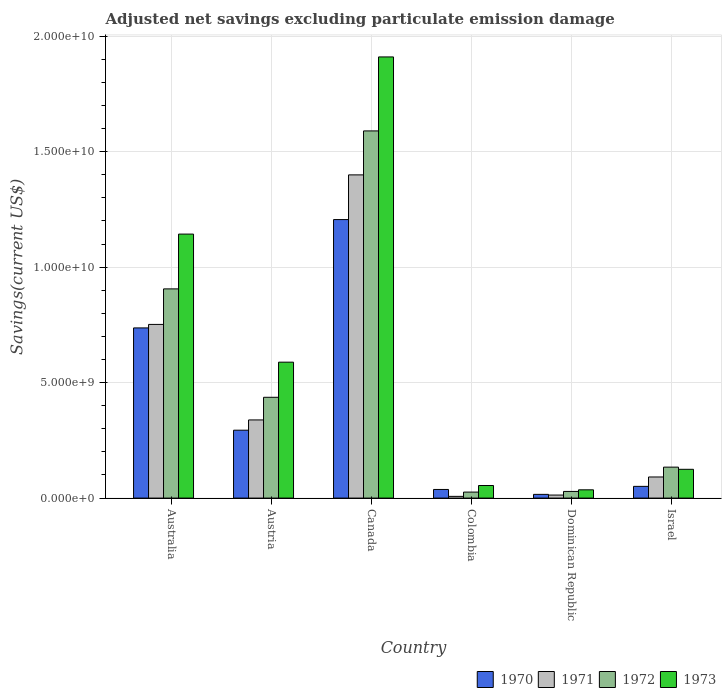How many different coloured bars are there?
Give a very brief answer. 4. How many groups of bars are there?
Give a very brief answer. 6. How many bars are there on the 6th tick from the right?
Keep it short and to the point. 4. What is the label of the 4th group of bars from the left?
Provide a short and direct response. Colombia. In how many cases, is the number of bars for a given country not equal to the number of legend labels?
Offer a terse response. 0. What is the adjusted net savings in 1971 in Dominican Republic?
Ensure brevity in your answer.  1.32e+08. Across all countries, what is the maximum adjusted net savings in 1972?
Ensure brevity in your answer.  1.59e+1. Across all countries, what is the minimum adjusted net savings in 1971?
Make the answer very short. 7.46e+07. In which country was the adjusted net savings in 1972 maximum?
Your answer should be very brief. Canada. In which country was the adjusted net savings in 1972 minimum?
Provide a succinct answer. Colombia. What is the total adjusted net savings in 1973 in the graph?
Provide a short and direct response. 3.86e+1. What is the difference between the adjusted net savings in 1972 in Austria and that in Canada?
Offer a very short reply. -1.15e+1. What is the difference between the adjusted net savings in 1971 in Canada and the adjusted net savings in 1970 in Israel?
Offer a very short reply. 1.35e+1. What is the average adjusted net savings in 1970 per country?
Provide a short and direct response. 3.90e+09. What is the difference between the adjusted net savings of/in 1970 and adjusted net savings of/in 1972 in Austria?
Provide a succinct answer. -1.43e+09. In how many countries, is the adjusted net savings in 1970 greater than 1000000000 US$?
Keep it short and to the point. 3. What is the ratio of the adjusted net savings in 1970 in Dominican Republic to that in Israel?
Your response must be concise. 0.32. Is the adjusted net savings in 1971 in Australia less than that in Austria?
Make the answer very short. No. What is the difference between the highest and the second highest adjusted net savings in 1970?
Make the answer very short. 9.12e+09. What is the difference between the highest and the lowest adjusted net savings in 1970?
Keep it short and to the point. 1.19e+1. Is the sum of the adjusted net savings in 1972 in Canada and Colombia greater than the maximum adjusted net savings in 1973 across all countries?
Give a very brief answer. No. Is it the case that in every country, the sum of the adjusted net savings in 1972 and adjusted net savings in 1973 is greater than the sum of adjusted net savings in 1971 and adjusted net savings in 1970?
Keep it short and to the point. No. How many bars are there?
Offer a very short reply. 24. Are all the bars in the graph horizontal?
Your response must be concise. No. What is the difference between two consecutive major ticks on the Y-axis?
Your response must be concise. 5.00e+09. How are the legend labels stacked?
Provide a succinct answer. Horizontal. What is the title of the graph?
Your response must be concise. Adjusted net savings excluding particulate emission damage. Does "2003" appear as one of the legend labels in the graph?
Provide a short and direct response. No. What is the label or title of the X-axis?
Provide a short and direct response. Country. What is the label or title of the Y-axis?
Offer a very short reply. Savings(current US$). What is the Savings(current US$) in 1970 in Australia?
Ensure brevity in your answer.  7.37e+09. What is the Savings(current US$) in 1971 in Australia?
Your answer should be very brief. 7.52e+09. What is the Savings(current US$) in 1972 in Australia?
Ensure brevity in your answer.  9.06e+09. What is the Savings(current US$) of 1973 in Australia?
Give a very brief answer. 1.14e+1. What is the Savings(current US$) in 1970 in Austria?
Your response must be concise. 2.94e+09. What is the Savings(current US$) in 1971 in Austria?
Ensure brevity in your answer.  3.38e+09. What is the Savings(current US$) in 1972 in Austria?
Offer a very short reply. 4.37e+09. What is the Savings(current US$) in 1973 in Austria?
Your answer should be compact. 5.89e+09. What is the Savings(current US$) in 1970 in Canada?
Your answer should be very brief. 1.21e+1. What is the Savings(current US$) of 1971 in Canada?
Offer a terse response. 1.40e+1. What is the Savings(current US$) in 1972 in Canada?
Offer a terse response. 1.59e+1. What is the Savings(current US$) of 1973 in Canada?
Make the answer very short. 1.91e+1. What is the Savings(current US$) of 1970 in Colombia?
Provide a succinct answer. 3.74e+08. What is the Savings(current US$) in 1971 in Colombia?
Offer a terse response. 7.46e+07. What is the Savings(current US$) of 1972 in Colombia?
Offer a terse response. 2.60e+08. What is the Savings(current US$) in 1973 in Colombia?
Provide a succinct answer. 5.45e+08. What is the Savings(current US$) in 1970 in Dominican Republic?
Keep it short and to the point. 1.61e+08. What is the Savings(current US$) in 1971 in Dominican Republic?
Give a very brief answer. 1.32e+08. What is the Savings(current US$) of 1972 in Dominican Republic?
Your answer should be compact. 2.89e+08. What is the Savings(current US$) of 1973 in Dominican Republic?
Offer a terse response. 3.58e+08. What is the Savings(current US$) in 1970 in Israel?
Keep it short and to the point. 5.08e+08. What is the Savings(current US$) in 1971 in Israel?
Your answer should be very brief. 9.14e+08. What is the Savings(current US$) of 1972 in Israel?
Your answer should be very brief. 1.34e+09. What is the Savings(current US$) in 1973 in Israel?
Ensure brevity in your answer.  1.25e+09. Across all countries, what is the maximum Savings(current US$) in 1970?
Ensure brevity in your answer.  1.21e+1. Across all countries, what is the maximum Savings(current US$) of 1971?
Offer a very short reply. 1.40e+1. Across all countries, what is the maximum Savings(current US$) of 1972?
Your response must be concise. 1.59e+1. Across all countries, what is the maximum Savings(current US$) of 1973?
Keep it short and to the point. 1.91e+1. Across all countries, what is the minimum Savings(current US$) in 1970?
Give a very brief answer. 1.61e+08. Across all countries, what is the minimum Savings(current US$) in 1971?
Offer a very short reply. 7.46e+07. Across all countries, what is the minimum Savings(current US$) of 1972?
Keep it short and to the point. 2.60e+08. Across all countries, what is the minimum Savings(current US$) in 1973?
Keep it short and to the point. 3.58e+08. What is the total Savings(current US$) in 1970 in the graph?
Your answer should be compact. 2.34e+1. What is the total Savings(current US$) of 1971 in the graph?
Offer a very short reply. 2.60e+1. What is the total Savings(current US$) in 1972 in the graph?
Ensure brevity in your answer.  3.12e+1. What is the total Savings(current US$) in 1973 in the graph?
Your answer should be very brief. 3.86e+1. What is the difference between the Savings(current US$) in 1970 in Australia and that in Austria?
Provide a succinct answer. 4.43e+09. What is the difference between the Savings(current US$) in 1971 in Australia and that in Austria?
Give a very brief answer. 4.14e+09. What is the difference between the Savings(current US$) of 1972 in Australia and that in Austria?
Provide a short and direct response. 4.69e+09. What is the difference between the Savings(current US$) of 1973 in Australia and that in Austria?
Keep it short and to the point. 5.55e+09. What is the difference between the Savings(current US$) of 1970 in Australia and that in Canada?
Offer a terse response. -4.69e+09. What is the difference between the Savings(current US$) in 1971 in Australia and that in Canada?
Keep it short and to the point. -6.48e+09. What is the difference between the Savings(current US$) in 1972 in Australia and that in Canada?
Your response must be concise. -6.84e+09. What is the difference between the Savings(current US$) of 1973 in Australia and that in Canada?
Provide a short and direct response. -7.67e+09. What is the difference between the Savings(current US$) of 1970 in Australia and that in Colombia?
Make the answer very short. 7.00e+09. What is the difference between the Savings(current US$) of 1971 in Australia and that in Colombia?
Make the answer very short. 7.45e+09. What is the difference between the Savings(current US$) in 1972 in Australia and that in Colombia?
Keep it short and to the point. 8.80e+09. What is the difference between the Savings(current US$) of 1973 in Australia and that in Colombia?
Your answer should be very brief. 1.09e+1. What is the difference between the Savings(current US$) of 1970 in Australia and that in Dominican Republic?
Your answer should be very brief. 7.21e+09. What is the difference between the Savings(current US$) of 1971 in Australia and that in Dominican Republic?
Your response must be concise. 7.39e+09. What is the difference between the Savings(current US$) of 1972 in Australia and that in Dominican Republic?
Provide a succinct answer. 8.77e+09. What is the difference between the Savings(current US$) of 1973 in Australia and that in Dominican Republic?
Your response must be concise. 1.11e+1. What is the difference between the Savings(current US$) of 1970 in Australia and that in Israel?
Your response must be concise. 6.86e+09. What is the difference between the Savings(current US$) of 1971 in Australia and that in Israel?
Keep it short and to the point. 6.61e+09. What is the difference between the Savings(current US$) of 1972 in Australia and that in Israel?
Your response must be concise. 7.72e+09. What is the difference between the Savings(current US$) in 1973 in Australia and that in Israel?
Give a very brief answer. 1.02e+1. What is the difference between the Savings(current US$) of 1970 in Austria and that in Canada?
Provide a short and direct response. -9.12e+09. What is the difference between the Savings(current US$) in 1971 in Austria and that in Canada?
Your answer should be very brief. -1.06e+1. What is the difference between the Savings(current US$) of 1972 in Austria and that in Canada?
Your answer should be very brief. -1.15e+1. What is the difference between the Savings(current US$) in 1973 in Austria and that in Canada?
Your answer should be compact. -1.32e+1. What is the difference between the Savings(current US$) of 1970 in Austria and that in Colombia?
Your answer should be compact. 2.57e+09. What is the difference between the Savings(current US$) in 1971 in Austria and that in Colombia?
Your response must be concise. 3.31e+09. What is the difference between the Savings(current US$) in 1972 in Austria and that in Colombia?
Offer a terse response. 4.11e+09. What is the difference between the Savings(current US$) of 1973 in Austria and that in Colombia?
Make the answer very short. 5.34e+09. What is the difference between the Savings(current US$) of 1970 in Austria and that in Dominican Republic?
Provide a succinct answer. 2.78e+09. What is the difference between the Savings(current US$) of 1971 in Austria and that in Dominican Republic?
Your response must be concise. 3.25e+09. What is the difference between the Savings(current US$) of 1972 in Austria and that in Dominican Republic?
Your answer should be compact. 4.08e+09. What is the difference between the Savings(current US$) of 1973 in Austria and that in Dominican Republic?
Offer a terse response. 5.53e+09. What is the difference between the Savings(current US$) in 1970 in Austria and that in Israel?
Keep it short and to the point. 2.43e+09. What is the difference between the Savings(current US$) in 1971 in Austria and that in Israel?
Offer a very short reply. 2.47e+09. What is the difference between the Savings(current US$) in 1972 in Austria and that in Israel?
Your response must be concise. 3.02e+09. What is the difference between the Savings(current US$) of 1973 in Austria and that in Israel?
Your answer should be very brief. 4.64e+09. What is the difference between the Savings(current US$) of 1970 in Canada and that in Colombia?
Give a very brief answer. 1.17e+1. What is the difference between the Savings(current US$) in 1971 in Canada and that in Colombia?
Keep it short and to the point. 1.39e+1. What is the difference between the Savings(current US$) in 1972 in Canada and that in Colombia?
Make the answer very short. 1.56e+1. What is the difference between the Savings(current US$) in 1973 in Canada and that in Colombia?
Provide a succinct answer. 1.86e+1. What is the difference between the Savings(current US$) of 1970 in Canada and that in Dominican Republic?
Provide a succinct answer. 1.19e+1. What is the difference between the Savings(current US$) in 1971 in Canada and that in Dominican Republic?
Offer a very short reply. 1.39e+1. What is the difference between the Savings(current US$) in 1972 in Canada and that in Dominican Republic?
Make the answer very short. 1.56e+1. What is the difference between the Savings(current US$) of 1973 in Canada and that in Dominican Republic?
Ensure brevity in your answer.  1.87e+1. What is the difference between the Savings(current US$) of 1970 in Canada and that in Israel?
Make the answer very short. 1.16e+1. What is the difference between the Savings(current US$) in 1971 in Canada and that in Israel?
Your answer should be very brief. 1.31e+1. What is the difference between the Savings(current US$) in 1972 in Canada and that in Israel?
Your answer should be compact. 1.46e+1. What is the difference between the Savings(current US$) of 1973 in Canada and that in Israel?
Provide a succinct answer. 1.79e+1. What is the difference between the Savings(current US$) of 1970 in Colombia and that in Dominican Republic?
Provide a succinct answer. 2.13e+08. What is the difference between the Savings(current US$) of 1971 in Colombia and that in Dominican Republic?
Your response must be concise. -5.69e+07. What is the difference between the Savings(current US$) of 1972 in Colombia and that in Dominican Republic?
Your answer should be compact. -2.84e+07. What is the difference between the Savings(current US$) of 1973 in Colombia and that in Dominican Republic?
Give a very brief answer. 1.87e+08. What is the difference between the Savings(current US$) in 1970 in Colombia and that in Israel?
Provide a succinct answer. -1.34e+08. What is the difference between the Savings(current US$) of 1971 in Colombia and that in Israel?
Your answer should be very brief. -8.40e+08. What is the difference between the Savings(current US$) of 1972 in Colombia and that in Israel?
Ensure brevity in your answer.  -1.08e+09. What is the difference between the Savings(current US$) of 1973 in Colombia and that in Israel?
Your answer should be very brief. -7.02e+08. What is the difference between the Savings(current US$) of 1970 in Dominican Republic and that in Israel?
Your answer should be compact. -3.47e+08. What is the difference between the Savings(current US$) in 1971 in Dominican Republic and that in Israel?
Ensure brevity in your answer.  -7.83e+08. What is the difference between the Savings(current US$) of 1972 in Dominican Republic and that in Israel?
Provide a succinct answer. -1.05e+09. What is the difference between the Savings(current US$) of 1973 in Dominican Republic and that in Israel?
Provide a short and direct response. -8.89e+08. What is the difference between the Savings(current US$) in 1970 in Australia and the Savings(current US$) in 1971 in Austria?
Give a very brief answer. 3.98e+09. What is the difference between the Savings(current US$) of 1970 in Australia and the Savings(current US$) of 1972 in Austria?
Provide a short and direct response. 3.00e+09. What is the difference between the Savings(current US$) of 1970 in Australia and the Savings(current US$) of 1973 in Austria?
Ensure brevity in your answer.  1.48e+09. What is the difference between the Savings(current US$) of 1971 in Australia and the Savings(current US$) of 1972 in Austria?
Offer a very short reply. 3.16e+09. What is the difference between the Savings(current US$) in 1971 in Australia and the Savings(current US$) in 1973 in Austria?
Provide a short and direct response. 1.63e+09. What is the difference between the Savings(current US$) of 1972 in Australia and the Savings(current US$) of 1973 in Austria?
Ensure brevity in your answer.  3.17e+09. What is the difference between the Savings(current US$) in 1970 in Australia and the Savings(current US$) in 1971 in Canada?
Ensure brevity in your answer.  -6.63e+09. What is the difference between the Savings(current US$) of 1970 in Australia and the Savings(current US$) of 1972 in Canada?
Provide a short and direct response. -8.53e+09. What is the difference between the Savings(current US$) of 1970 in Australia and the Savings(current US$) of 1973 in Canada?
Offer a terse response. -1.17e+1. What is the difference between the Savings(current US$) of 1971 in Australia and the Savings(current US$) of 1972 in Canada?
Your answer should be compact. -8.38e+09. What is the difference between the Savings(current US$) in 1971 in Australia and the Savings(current US$) in 1973 in Canada?
Your answer should be very brief. -1.16e+1. What is the difference between the Savings(current US$) in 1972 in Australia and the Savings(current US$) in 1973 in Canada?
Your response must be concise. -1.00e+1. What is the difference between the Savings(current US$) in 1970 in Australia and the Savings(current US$) in 1971 in Colombia?
Provide a succinct answer. 7.30e+09. What is the difference between the Savings(current US$) of 1970 in Australia and the Savings(current US$) of 1972 in Colombia?
Provide a succinct answer. 7.11e+09. What is the difference between the Savings(current US$) of 1970 in Australia and the Savings(current US$) of 1973 in Colombia?
Offer a very short reply. 6.83e+09. What is the difference between the Savings(current US$) of 1971 in Australia and the Savings(current US$) of 1972 in Colombia?
Make the answer very short. 7.26e+09. What is the difference between the Savings(current US$) in 1971 in Australia and the Savings(current US$) in 1973 in Colombia?
Offer a terse response. 6.98e+09. What is the difference between the Savings(current US$) of 1972 in Australia and the Savings(current US$) of 1973 in Colombia?
Provide a succinct answer. 8.51e+09. What is the difference between the Savings(current US$) of 1970 in Australia and the Savings(current US$) of 1971 in Dominican Republic?
Give a very brief answer. 7.24e+09. What is the difference between the Savings(current US$) of 1970 in Australia and the Savings(current US$) of 1972 in Dominican Republic?
Make the answer very short. 7.08e+09. What is the difference between the Savings(current US$) in 1970 in Australia and the Savings(current US$) in 1973 in Dominican Republic?
Make the answer very short. 7.01e+09. What is the difference between the Savings(current US$) of 1971 in Australia and the Savings(current US$) of 1972 in Dominican Republic?
Ensure brevity in your answer.  7.23e+09. What is the difference between the Savings(current US$) of 1971 in Australia and the Savings(current US$) of 1973 in Dominican Republic?
Keep it short and to the point. 7.16e+09. What is the difference between the Savings(current US$) in 1972 in Australia and the Savings(current US$) in 1973 in Dominican Republic?
Your answer should be compact. 8.70e+09. What is the difference between the Savings(current US$) of 1970 in Australia and the Savings(current US$) of 1971 in Israel?
Offer a terse response. 6.46e+09. What is the difference between the Savings(current US$) of 1970 in Australia and the Savings(current US$) of 1972 in Israel?
Offer a terse response. 6.03e+09. What is the difference between the Savings(current US$) in 1970 in Australia and the Savings(current US$) in 1973 in Israel?
Your response must be concise. 6.12e+09. What is the difference between the Savings(current US$) in 1971 in Australia and the Savings(current US$) in 1972 in Israel?
Make the answer very short. 6.18e+09. What is the difference between the Savings(current US$) in 1971 in Australia and the Savings(current US$) in 1973 in Israel?
Your response must be concise. 6.27e+09. What is the difference between the Savings(current US$) of 1972 in Australia and the Savings(current US$) of 1973 in Israel?
Your answer should be very brief. 7.81e+09. What is the difference between the Savings(current US$) of 1970 in Austria and the Savings(current US$) of 1971 in Canada?
Your answer should be very brief. -1.11e+1. What is the difference between the Savings(current US$) of 1970 in Austria and the Savings(current US$) of 1972 in Canada?
Provide a succinct answer. -1.30e+1. What is the difference between the Savings(current US$) of 1970 in Austria and the Savings(current US$) of 1973 in Canada?
Your response must be concise. -1.62e+1. What is the difference between the Savings(current US$) of 1971 in Austria and the Savings(current US$) of 1972 in Canada?
Keep it short and to the point. -1.25e+1. What is the difference between the Savings(current US$) in 1971 in Austria and the Savings(current US$) in 1973 in Canada?
Your response must be concise. -1.57e+1. What is the difference between the Savings(current US$) in 1972 in Austria and the Savings(current US$) in 1973 in Canada?
Offer a very short reply. -1.47e+1. What is the difference between the Savings(current US$) of 1970 in Austria and the Savings(current US$) of 1971 in Colombia?
Ensure brevity in your answer.  2.87e+09. What is the difference between the Savings(current US$) of 1970 in Austria and the Savings(current US$) of 1972 in Colombia?
Provide a short and direct response. 2.68e+09. What is the difference between the Savings(current US$) in 1970 in Austria and the Savings(current US$) in 1973 in Colombia?
Give a very brief answer. 2.40e+09. What is the difference between the Savings(current US$) in 1971 in Austria and the Savings(current US$) in 1972 in Colombia?
Your response must be concise. 3.12e+09. What is the difference between the Savings(current US$) in 1971 in Austria and the Savings(current US$) in 1973 in Colombia?
Ensure brevity in your answer.  2.84e+09. What is the difference between the Savings(current US$) in 1972 in Austria and the Savings(current US$) in 1973 in Colombia?
Your response must be concise. 3.82e+09. What is the difference between the Savings(current US$) of 1970 in Austria and the Savings(current US$) of 1971 in Dominican Republic?
Your response must be concise. 2.81e+09. What is the difference between the Savings(current US$) of 1970 in Austria and the Savings(current US$) of 1972 in Dominican Republic?
Your answer should be compact. 2.65e+09. What is the difference between the Savings(current US$) of 1970 in Austria and the Savings(current US$) of 1973 in Dominican Republic?
Offer a very short reply. 2.58e+09. What is the difference between the Savings(current US$) of 1971 in Austria and the Savings(current US$) of 1972 in Dominican Republic?
Your answer should be very brief. 3.10e+09. What is the difference between the Savings(current US$) of 1971 in Austria and the Savings(current US$) of 1973 in Dominican Republic?
Make the answer very short. 3.03e+09. What is the difference between the Savings(current US$) in 1972 in Austria and the Savings(current US$) in 1973 in Dominican Republic?
Your answer should be compact. 4.01e+09. What is the difference between the Savings(current US$) in 1970 in Austria and the Savings(current US$) in 1971 in Israel?
Make the answer very short. 2.03e+09. What is the difference between the Savings(current US$) of 1970 in Austria and the Savings(current US$) of 1972 in Israel?
Your answer should be compact. 1.60e+09. What is the difference between the Savings(current US$) of 1970 in Austria and the Savings(current US$) of 1973 in Israel?
Offer a very short reply. 1.69e+09. What is the difference between the Savings(current US$) in 1971 in Austria and the Savings(current US$) in 1972 in Israel?
Provide a short and direct response. 2.04e+09. What is the difference between the Savings(current US$) in 1971 in Austria and the Savings(current US$) in 1973 in Israel?
Ensure brevity in your answer.  2.14e+09. What is the difference between the Savings(current US$) of 1972 in Austria and the Savings(current US$) of 1973 in Israel?
Offer a terse response. 3.12e+09. What is the difference between the Savings(current US$) of 1970 in Canada and the Savings(current US$) of 1971 in Colombia?
Provide a succinct answer. 1.20e+1. What is the difference between the Savings(current US$) in 1970 in Canada and the Savings(current US$) in 1972 in Colombia?
Your response must be concise. 1.18e+1. What is the difference between the Savings(current US$) of 1970 in Canada and the Savings(current US$) of 1973 in Colombia?
Provide a short and direct response. 1.15e+1. What is the difference between the Savings(current US$) in 1971 in Canada and the Savings(current US$) in 1972 in Colombia?
Your answer should be compact. 1.37e+1. What is the difference between the Savings(current US$) in 1971 in Canada and the Savings(current US$) in 1973 in Colombia?
Provide a succinct answer. 1.35e+1. What is the difference between the Savings(current US$) in 1972 in Canada and the Savings(current US$) in 1973 in Colombia?
Offer a very short reply. 1.54e+1. What is the difference between the Savings(current US$) in 1970 in Canada and the Savings(current US$) in 1971 in Dominican Republic?
Offer a terse response. 1.19e+1. What is the difference between the Savings(current US$) in 1970 in Canada and the Savings(current US$) in 1972 in Dominican Republic?
Ensure brevity in your answer.  1.18e+1. What is the difference between the Savings(current US$) in 1970 in Canada and the Savings(current US$) in 1973 in Dominican Republic?
Keep it short and to the point. 1.17e+1. What is the difference between the Savings(current US$) in 1971 in Canada and the Savings(current US$) in 1972 in Dominican Republic?
Offer a terse response. 1.37e+1. What is the difference between the Savings(current US$) of 1971 in Canada and the Savings(current US$) of 1973 in Dominican Republic?
Your answer should be compact. 1.36e+1. What is the difference between the Savings(current US$) in 1972 in Canada and the Savings(current US$) in 1973 in Dominican Republic?
Your answer should be very brief. 1.55e+1. What is the difference between the Savings(current US$) of 1970 in Canada and the Savings(current US$) of 1971 in Israel?
Ensure brevity in your answer.  1.11e+1. What is the difference between the Savings(current US$) of 1970 in Canada and the Savings(current US$) of 1972 in Israel?
Offer a terse response. 1.07e+1. What is the difference between the Savings(current US$) in 1970 in Canada and the Savings(current US$) in 1973 in Israel?
Provide a succinct answer. 1.08e+1. What is the difference between the Savings(current US$) in 1971 in Canada and the Savings(current US$) in 1972 in Israel?
Offer a very short reply. 1.27e+1. What is the difference between the Savings(current US$) in 1971 in Canada and the Savings(current US$) in 1973 in Israel?
Ensure brevity in your answer.  1.27e+1. What is the difference between the Savings(current US$) in 1972 in Canada and the Savings(current US$) in 1973 in Israel?
Your answer should be compact. 1.47e+1. What is the difference between the Savings(current US$) in 1970 in Colombia and the Savings(current US$) in 1971 in Dominican Republic?
Your response must be concise. 2.42e+08. What is the difference between the Savings(current US$) in 1970 in Colombia and the Savings(current US$) in 1972 in Dominican Republic?
Give a very brief answer. 8.52e+07. What is the difference between the Savings(current US$) of 1970 in Colombia and the Savings(current US$) of 1973 in Dominican Republic?
Make the answer very short. 1.57e+07. What is the difference between the Savings(current US$) of 1971 in Colombia and the Savings(current US$) of 1972 in Dominican Republic?
Keep it short and to the point. -2.14e+08. What is the difference between the Savings(current US$) of 1971 in Colombia and the Savings(current US$) of 1973 in Dominican Republic?
Provide a short and direct response. -2.84e+08. What is the difference between the Savings(current US$) in 1972 in Colombia and the Savings(current US$) in 1973 in Dominican Republic?
Ensure brevity in your answer.  -9.79e+07. What is the difference between the Savings(current US$) of 1970 in Colombia and the Savings(current US$) of 1971 in Israel?
Make the answer very short. -5.40e+08. What is the difference between the Savings(current US$) of 1970 in Colombia and the Savings(current US$) of 1972 in Israel?
Provide a succinct answer. -9.67e+08. What is the difference between the Savings(current US$) of 1970 in Colombia and the Savings(current US$) of 1973 in Israel?
Provide a short and direct response. -8.73e+08. What is the difference between the Savings(current US$) of 1971 in Colombia and the Savings(current US$) of 1972 in Israel?
Keep it short and to the point. -1.27e+09. What is the difference between the Savings(current US$) of 1971 in Colombia and the Savings(current US$) of 1973 in Israel?
Ensure brevity in your answer.  -1.17e+09. What is the difference between the Savings(current US$) in 1972 in Colombia and the Savings(current US$) in 1973 in Israel?
Offer a terse response. -9.87e+08. What is the difference between the Savings(current US$) of 1970 in Dominican Republic and the Savings(current US$) of 1971 in Israel?
Offer a terse response. -7.53e+08. What is the difference between the Savings(current US$) in 1970 in Dominican Republic and the Savings(current US$) in 1972 in Israel?
Your response must be concise. -1.18e+09. What is the difference between the Savings(current US$) in 1970 in Dominican Republic and the Savings(current US$) in 1973 in Israel?
Give a very brief answer. -1.09e+09. What is the difference between the Savings(current US$) of 1971 in Dominican Republic and the Savings(current US$) of 1972 in Israel?
Give a very brief answer. -1.21e+09. What is the difference between the Savings(current US$) of 1971 in Dominican Republic and the Savings(current US$) of 1973 in Israel?
Give a very brief answer. -1.12e+09. What is the difference between the Savings(current US$) in 1972 in Dominican Republic and the Savings(current US$) in 1973 in Israel?
Make the answer very short. -9.58e+08. What is the average Savings(current US$) of 1970 per country?
Provide a short and direct response. 3.90e+09. What is the average Savings(current US$) in 1971 per country?
Provide a succinct answer. 4.34e+09. What is the average Savings(current US$) of 1972 per country?
Your answer should be very brief. 5.20e+09. What is the average Savings(current US$) in 1973 per country?
Offer a very short reply. 6.43e+09. What is the difference between the Savings(current US$) in 1970 and Savings(current US$) in 1971 in Australia?
Offer a very short reply. -1.51e+08. What is the difference between the Savings(current US$) of 1970 and Savings(current US$) of 1972 in Australia?
Your answer should be very brief. -1.69e+09. What is the difference between the Savings(current US$) in 1970 and Savings(current US$) in 1973 in Australia?
Your response must be concise. -4.06e+09. What is the difference between the Savings(current US$) of 1971 and Savings(current US$) of 1972 in Australia?
Make the answer very short. -1.54e+09. What is the difference between the Savings(current US$) in 1971 and Savings(current US$) in 1973 in Australia?
Offer a terse response. -3.91e+09. What is the difference between the Savings(current US$) of 1972 and Savings(current US$) of 1973 in Australia?
Your answer should be very brief. -2.37e+09. What is the difference between the Savings(current US$) in 1970 and Savings(current US$) in 1971 in Austria?
Make the answer very short. -4.45e+08. What is the difference between the Savings(current US$) of 1970 and Savings(current US$) of 1972 in Austria?
Offer a terse response. -1.43e+09. What is the difference between the Savings(current US$) in 1970 and Savings(current US$) in 1973 in Austria?
Provide a short and direct response. -2.95e+09. What is the difference between the Savings(current US$) of 1971 and Savings(current US$) of 1972 in Austria?
Give a very brief answer. -9.81e+08. What is the difference between the Savings(current US$) of 1971 and Savings(current US$) of 1973 in Austria?
Keep it short and to the point. -2.50e+09. What is the difference between the Savings(current US$) in 1972 and Savings(current US$) in 1973 in Austria?
Your answer should be very brief. -1.52e+09. What is the difference between the Savings(current US$) of 1970 and Savings(current US$) of 1971 in Canada?
Make the answer very short. -1.94e+09. What is the difference between the Savings(current US$) in 1970 and Savings(current US$) in 1972 in Canada?
Your answer should be very brief. -3.84e+09. What is the difference between the Savings(current US$) of 1970 and Savings(current US$) of 1973 in Canada?
Your answer should be compact. -7.04e+09. What is the difference between the Savings(current US$) of 1971 and Savings(current US$) of 1972 in Canada?
Provide a short and direct response. -1.90e+09. What is the difference between the Savings(current US$) in 1971 and Savings(current US$) in 1973 in Canada?
Your answer should be compact. -5.11e+09. What is the difference between the Savings(current US$) in 1972 and Savings(current US$) in 1973 in Canada?
Your response must be concise. -3.20e+09. What is the difference between the Savings(current US$) in 1970 and Savings(current US$) in 1971 in Colombia?
Your response must be concise. 2.99e+08. What is the difference between the Savings(current US$) in 1970 and Savings(current US$) in 1972 in Colombia?
Your answer should be very brief. 1.14e+08. What is the difference between the Savings(current US$) in 1970 and Savings(current US$) in 1973 in Colombia?
Your answer should be compact. -1.71e+08. What is the difference between the Savings(current US$) in 1971 and Savings(current US$) in 1972 in Colombia?
Make the answer very short. -1.86e+08. What is the difference between the Savings(current US$) in 1971 and Savings(current US$) in 1973 in Colombia?
Make the answer very short. -4.70e+08. What is the difference between the Savings(current US$) in 1972 and Savings(current US$) in 1973 in Colombia?
Your answer should be very brief. -2.85e+08. What is the difference between the Savings(current US$) in 1970 and Savings(current US$) in 1971 in Dominican Republic?
Your response must be concise. 2.96e+07. What is the difference between the Savings(current US$) of 1970 and Savings(current US$) of 1972 in Dominican Republic?
Provide a short and direct response. -1.28e+08. What is the difference between the Savings(current US$) in 1970 and Savings(current US$) in 1973 in Dominican Republic?
Keep it short and to the point. -1.97e+08. What is the difference between the Savings(current US$) of 1971 and Savings(current US$) of 1972 in Dominican Republic?
Offer a terse response. -1.57e+08. What is the difference between the Savings(current US$) in 1971 and Savings(current US$) in 1973 in Dominican Republic?
Give a very brief answer. -2.27e+08. What is the difference between the Savings(current US$) in 1972 and Savings(current US$) in 1973 in Dominican Republic?
Provide a succinct answer. -6.95e+07. What is the difference between the Savings(current US$) in 1970 and Savings(current US$) in 1971 in Israel?
Give a very brief answer. -4.06e+08. What is the difference between the Savings(current US$) in 1970 and Savings(current US$) in 1972 in Israel?
Your response must be concise. -8.33e+08. What is the difference between the Savings(current US$) of 1970 and Savings(current US$) of 1973 in Israel?
Give a very brief answer. -7.39e+08. What is the difference between the Savings(current US$) in 1971 and Savings(current US$) in 1972 in Israel?
Your answer should be compact. -4.27e+08. What is the difference between the Savings(current US$) in 1971 and Savings(current US$) in 1973 in Israel?
Make the answer very short. -3.33e+08. What is the difference between the Savings(current US$) of 1972 and Savings(current US$) of 1973 in Israel?
Your response must be concise. 9.40e+07. What is the ratio of the Savings(current US$) in 1970 in Australia to that in Austria?
Provide a short and direct response. 2.51. What is the ratio of the Savings(current US$) of 1971 in Australia to that in Austria?
Your answer should be compact. 2.22. What is the ratio of the Savings(current US$) in 1972 in Australia to that in Austria?
Your answer should be very brief. 2.08. What is the ratio of the Savings(current US$) in 1973 in Australia to that in Austria?
Your response must be concise. 1.94. What is the ratio of the Savings(current US$) of 1970 in Australia to that in Canada?
Make the answer very short. 0.61. What is the ratio of the Savings(current US$) in 1971 in Australia to that in Canada?
Ensure brevity in your answer.  0.54. What is the ratio of the Savings(current US$) of 1972 in Australia to that in Canada?
Give a very brief answer. 0.57. What is the ratio of the Savings(current US$) in 1973 in Australia to that in Canada?
Offer a very short reply. 0.6. What is the ratio of the Savings(current US$) in 1970 in Australia to that in Colombia?
Provide a short and direct response. 19.71. What is the ratio of the Savings(current US$) in 1971 in Australia to that in Colombia?
Offer a very short reply. 100.8. What is the ratio of the Savings(current US$) in 1972 in Australia to that in Colombia?
Ensure brevity in your answer.  34.81. What is the ratio of the Savings(current US$) of 1973 in Australia to that in Colombia?
Offer a very short reply. 20.98. What is the ratio of the Savings(current US$) in 1970 in Australia to that in Dominican Republic?
Provide a short and direct response. 45.75. What is the ratio of the Savings(current US$) in 1971 in Australia to that in Dominican Republic?
Your answer should be very brief. 57.18. What is the ratio of the Savings(current US$) in 1972 in Australia to that in Dominican Republic?
Provide a short and direct response. 31.38. What is the ratio of the Savings(current US$) of 1973 in Australia to that in Dominican Republic?
Your answer should be compact. 31.92. What is the ratio of the Savings(current US$) in 1970 in Australia to that in Israel?
Provide a succinct answer. 14.51. What is the ratio of the Savings(current US$) in 1971 in Australia to that in Israel?
Your answer should be very brief. 8.23. What is the ratio of the Savings(current US$) in 1972 in Australia to that in Israel?
Provide a succinct answer. 6.76. What is the ratio of the Savings(current US$) in 1973 in Australia to that in Israel?
Offer a terse response. 9.17. What is the ratio of the Savings(current US$) of 1970 in Austria to that in Canada?
Your answer should be compact. 0.24. What is the ratio of the Savings(current US$) of 1971 in Austria to that in Canada?
Ensure brevity in your answer.  0.24. What is the ratio of the Savings(current US$) in 1972 in Austria to that in Canada?
Your answer should be very brief. 0.27. What is the ratio of the Savings(current US$) in 1973 in Austria to that in Canada?
Provide a succinct answer. 0.31. What is the ratio of the Savings(current US$) in 1970 in Austria to that in Colombia?
Your answer should be very brief. 7.86. What is the ratio of the Savings(current US$) of 1971 in Austria to that in Colombia?
Keep it short and to the point. 45.37. What is the ratio of the Savings(current US$) in 1972 in Austria to that in Colombia?
Keep it short and to the point. 16.77. What is the ratio of the Savings(current US$) in 1973 in Austria to that in Colombia?
Give a very brief answer. 10.8. What is the ratio of the Savings(current US$) of 1970 in Austria to that in Dominican Republic?
Your response must be concise. 18.25. What is the ratio of the Savings(current US$) of 1971 in Austria to that in Dominican Republic?
Offer a very short reply. 25.73. What is the ratio of the Savings(current US$) in 1972 in Austria to that in Dominican Republic?
Your answer should be very brief. 15.12. What is the ratio of the Savings(current US$) of 1973 in Austria to that in Dominican Republic?
Your response must be concise. 16.43. What is the ratio of the Savings(current US$) of 1970 in Austria to that in Israel?
Your answer should be compact. 5.79. What is the ratio of the Savings(current US$) in 1971 in Austria to that in Israel?
Your response must be concise. 3.7. What is the ratio of the Savings(current US$) of 1972 in Austria to that in Israel?
Offer a terse response. 3.26. What is the ratio of the Savings(current US$) of 1973 in Austria to that in Israel?
Give a very brief answer. 4.72. What is the ratio of the Savings(current US$) in 1970 in Canada to that in Colombia?
Provide a short and direct response. 32.26. What is the ratio of the Savings(current US$) of 1971 in Canada to that in Colombia?
Keep it short and to the point. 187.59. What is the ratio of the Savings(current US$) of 1972 in Canada to that in Colombia?
Provide a short and direct response. 61.09. What is the ratio of the Savings(current US$) of 1973 in Canada to that in Colombia?
Ensure brevity in your answer.  35.07. What is the ratio of the Savings(current US$) of 1970 in Canada to that in Dominican Republic?
Provide a short and direct response. 74.87. What is the ratio of the Savings(current US$) of 1971 in Canada to that in Dominican Republic?
Offer a very short reply. 106.4. What is the ratio of the Savings(current US$) in 1972 in Canada to that in Dominican Republic?
Provide a short and direct response. 55.08. What is the ratio of the Savings(current US$) of 1973 in Canada to that in Dominican Republic?
Make the answer very short. 53.33. What is the ratio of the Savings(current US$) of 1970 in Canada to that in Israel?
Your answer should be very brief. 23.75. What is the ratio of the Savings(current US$) of 1971 in Canada to that in Israel?
Offer a terse response. 15.31. What is the ratio of the Savings(current US$) in 1972 in Canada to that in Israel?
Your answer should be very brief. 11.86. What is the ratio of the Savings(current US$) in 1973 in Canada to that in Israel?
Provide a succinct answer. 15.32. What is the ratio of the Savings(current US$) of 1970 in Colombia to that in Dominican Republic?
Your answer should be compact. 2.32. What is the ratio of the Savings(current US$) in 1971 in Colombia to that in Dominican Republic?
Provide a succinct answer. 0.57. What is the ratio of the Savings(current US$) in 1972 in Colombia to that in Dominican Republic?
Ensure brevity in your answer.  0.9. What is the ratio of the Savings(current US$) of 1973 in Colombia to that in Dominican Republic?
Ensure brevity in your answer.  1.52. What is the ratio of the Savings(current US$) in 1970 in Colombia to that in Israel?
Provide a short and direct response. 0.74. What is the ratio of the Savings(current US$) in 1971 in Colombia to that in Israel?
Your response must be concise. 0.08. What is the ratio of the Savings(current US$) of 1972 in Colombia to that in Israel?
Keep it short and to the point. 0.19. What is the ratio of the Savings(current US$) in 1973 in Colombia to that in Israel?
Give a very brief answer. 0.44. What is the ratio of the Savings(current US$) in 1970 in Dominican Republic to that in Israel?
Offer a very short reply. 0.32. What is the ratio of the Savings(current US$) of 1971 in Dominican Republic to that in Israel?
Give a very brief answer. 0.14. What is the ratio of the Savings(current US$) of 1972 in Dominican Republic to that in Israel?
Provide a short and direct response. 0.22. What is the ratio of the Savings(current US$) in 1973 in Dominican Republic to that in Israel?
Provide a succinct answer. 0.29. What is the difference between the highest and the second highest Savings(current US$) in 1970?
Give a very brief answer. 4.69e+09. What is the difference between the highest and the second highest Savings(current US$) of 1971?
Ensure brevity in your answer.  6.48e+09. What is the difference between the highest and the second highest Savings(current US$) in 1972?
Your response must be concise. 6.84e+09. What is the difference between the highest and the second highest Savings(current US$) in 1973?
Provide a short and direct response. 7.67e+09. What is the difference between the highest and the lowest Savings(current US$) in 1970?
Your answer should be compact. 1.19e+1. What is the difference between the highest and the lowest Savings(current US$) of 1971?
Your answer should be very brief. 1.39e+1. What is the difference between the highest and the lowest Savings(current US$) in 1972?
Keep it short and to the point. 1.56e+1. What is the difference between the highest and the lowest Savings(current US$) in 1973?
Offer a very short reply. 1.87e+1. 